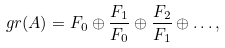Convert formula to latex. <formula><loc_0><loc_0><loc_500><loc_500>\ g r ( A ) = F _ { 0 } \oplus \frac { F _ { 1 } } { F _ { 0 } } \oplus \frac { F _ { 2 } } { F _ { 1 } } \oplus \dots ,</formula> 